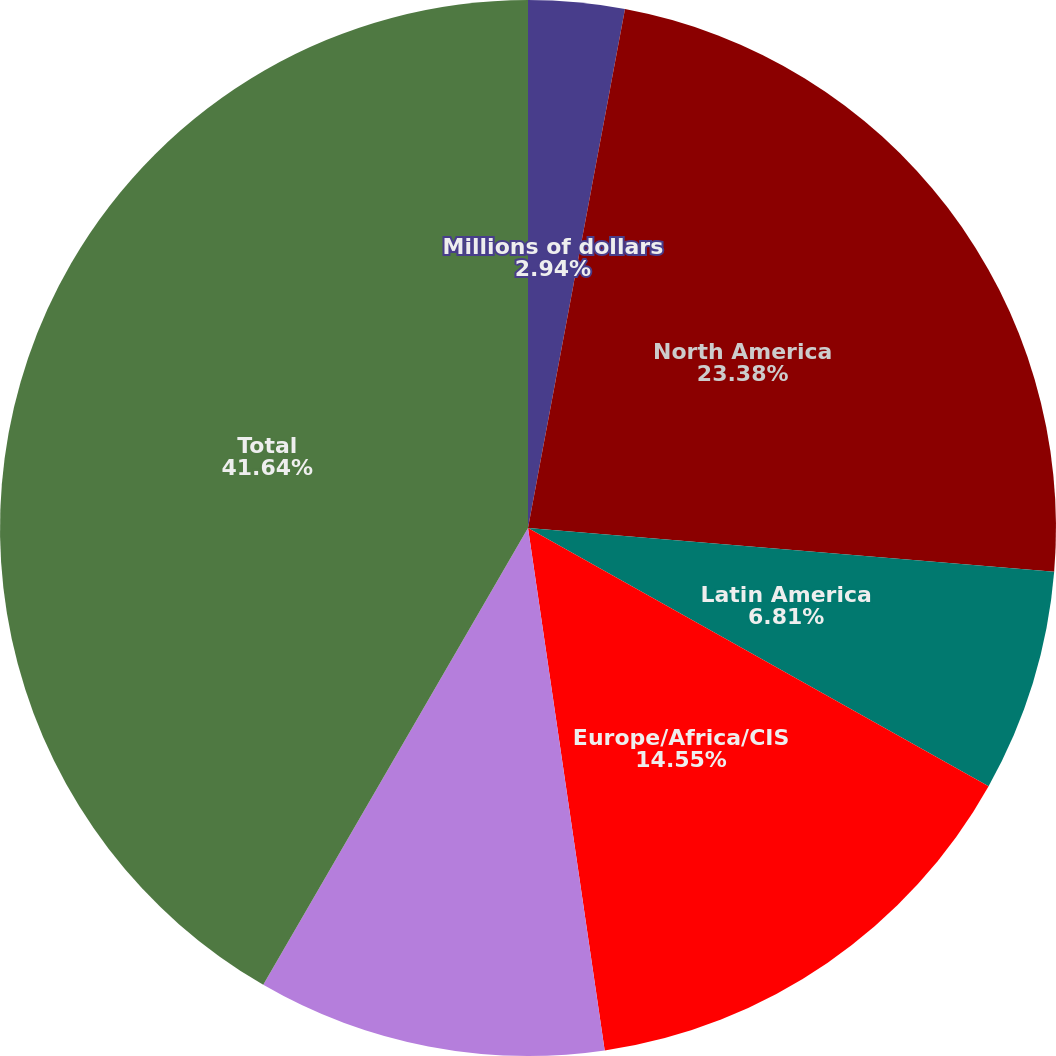Convert chart to OTSL. <chart><loc_0><loc_0><loc_500><loc_500><pie_chart><fcel>Millions of dollars<fcel>North America<fcel>Latin America<fcel>Europe/Africa/CIS<fcel>Middle East/Asia<fcel>Total<nl><fcel>2.94%<fcel>23.38%<fcel>6.81%<fcel>14.55%<fcel>10.68%<fcel>41.64%<nl></chart> 